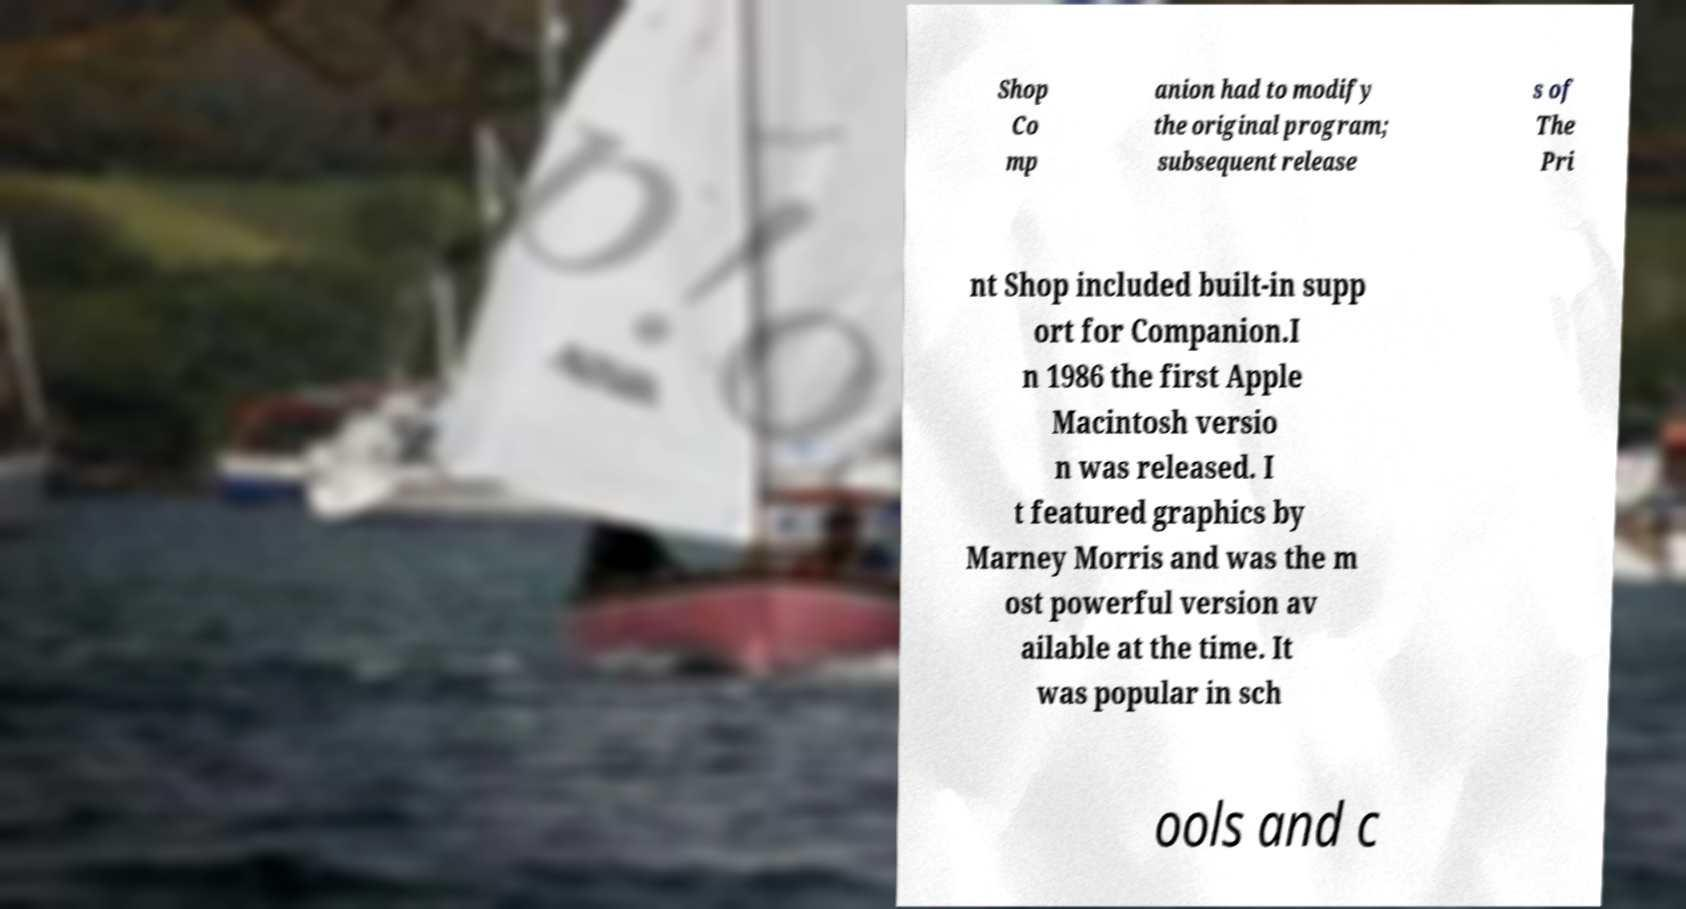Could you extract and type out the text from this image? Shop Co mp anion had to modify the original program; subsequent release s of The Pri nt Shop included built-in supp ort for Companion.I n 1986 the first Apple Macintosh versio n was released. I t featured graphics by Marney Morris and was the m ost powerful version av ailable at the time. It was popular in sch ools and c 